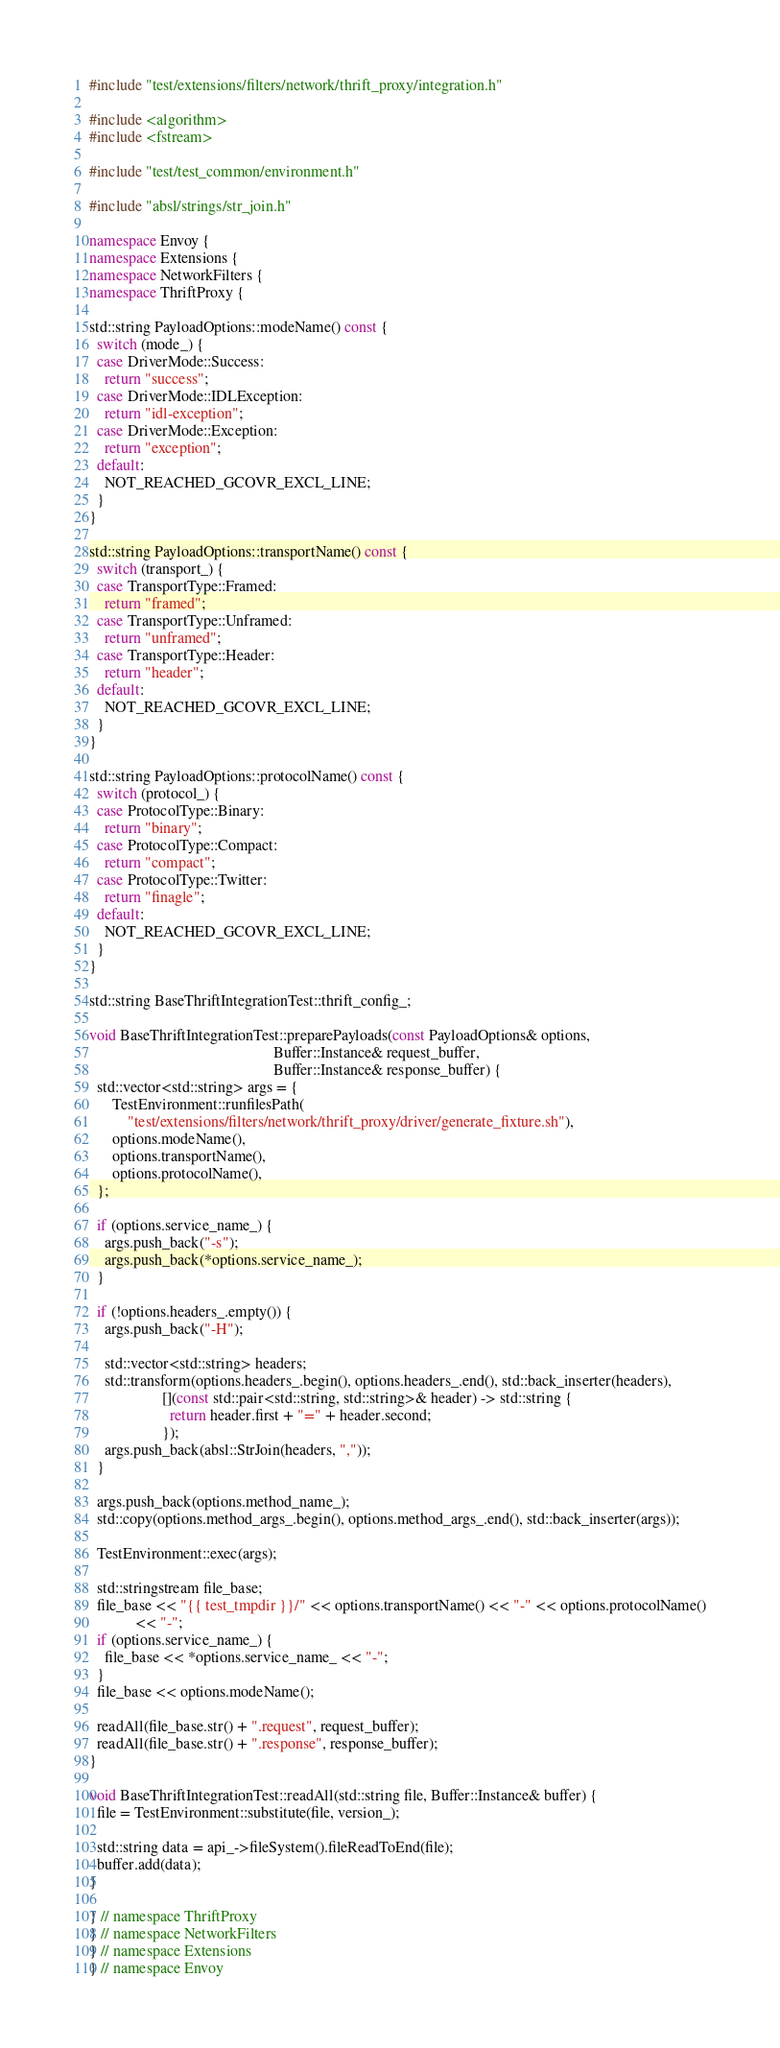Convert code to text. <code><loc_0><loc_0><loc_500><loc_500><_C++_>#include "test/extensions/filters/network/thrift_proxy/integration.h"

#include <algorithm>
#include <fstream>

#include "test/test_common/environment.h"

#include "absl/strings/str_join.h"

namespace Envoy {
namespace Extensions {
namespace NetworkFilters {
namespace ThriftProxy {

std::string PayloadOptions::modeName() const {
  switch (mode_) {
  case DriverMode::Success:
    return "success";
  case DriverMode::IDLException:
    return "idl-exception";
  case DriverMode::Exception:
    return "exception";
  default:
    NOT_REACHED_GCOVR_EXCL_LINE;
  }
}

std::string PayloadOptions::transportName() const {
  switch (transport_) {
  case TransportType::Framed:
    return "framed";
  case TransportType::Unframed:
    return "unframed";
  case TransportType::Header:
    return "header";
  default:
    NOT_REACHED_GCOVR_EXCL_LINE;
  }
}

std::string PayloadOptions::protocolName() const {
  switch (protocol_) {
  case ProtocolType::Binary:
    return "binary";
  case ProtocolType::Compact:
    return "compact";
  case ProtocolType::Twitter:
    return "finagle";
  default:
    NOT_REACHED_GCOVR_EXCL_LINE;
  }
}

std::string BaseThriftIntegrationTest::thrift_config_;

void BaseThriftIntegrationTest::preparePayloads(const PayloadOptions& options,
                                                Buffer::Instance& request_buffer,
                                                Buffer::Instance& response_buffer) {
  std::vector<std::string> args = {
      TestEnvironment::runfilesPath(
          "test/extensions/filters/network/thrift_proxy/driver/generate_fixture.sh"),
      options.modeName(),
      options.transportName(),
      options.protocolName(),
  };

  if (options.service_name_) {
    args.push_back("-s");
    args.push_back(*options.service_name_);
  }

  if (!options.headers_.empty()) {
    args.push_back("-H");

    std::vector<std::string> headers;
    std::transform(options.headers_.begin(), options.headers_.end(), std::back_inserter(headers),
                   [](const std::pair<std::string, std::string>& header) -> std::string {
                     return header.first + "=" + header.second;
                   });
    args.push_back(absl::StrJoin(headers, ","));
  }

  args.push_back(options.method_name_);
  std::copy(options.method_args_.begin(), options.method_args_.end(), std::back_inserter(args));

  TestEnvironment::exec(args);

  std::stringstream file_base;
  file_base << "{{ test_tmpdir }}/" << options.transportName() << "-" << options.protocolName()
            << "-";
  if (options.service_name_) {
    file_base << *options.service_name_ << "-";
  }
  file_base << options.modeName();

  readAll(file_base.str() + ".request", request_buffer);
  readAll(file_base.str() + ".response", response_buffer);
}

void BaseThriftIntegrationTest::readAll(std::string file, Buffer::Instance& buffer) {
  file = TestEnvironment::substitute(file, version_);

  std::string data = api_->fileSystem().fileReadToEnd(file);
  buffer.add(data);
}

} // namespace ThriftProxy
} // namespace NetworkFilters
} // namespace Extensions
} // namespace Envoy
</code> 